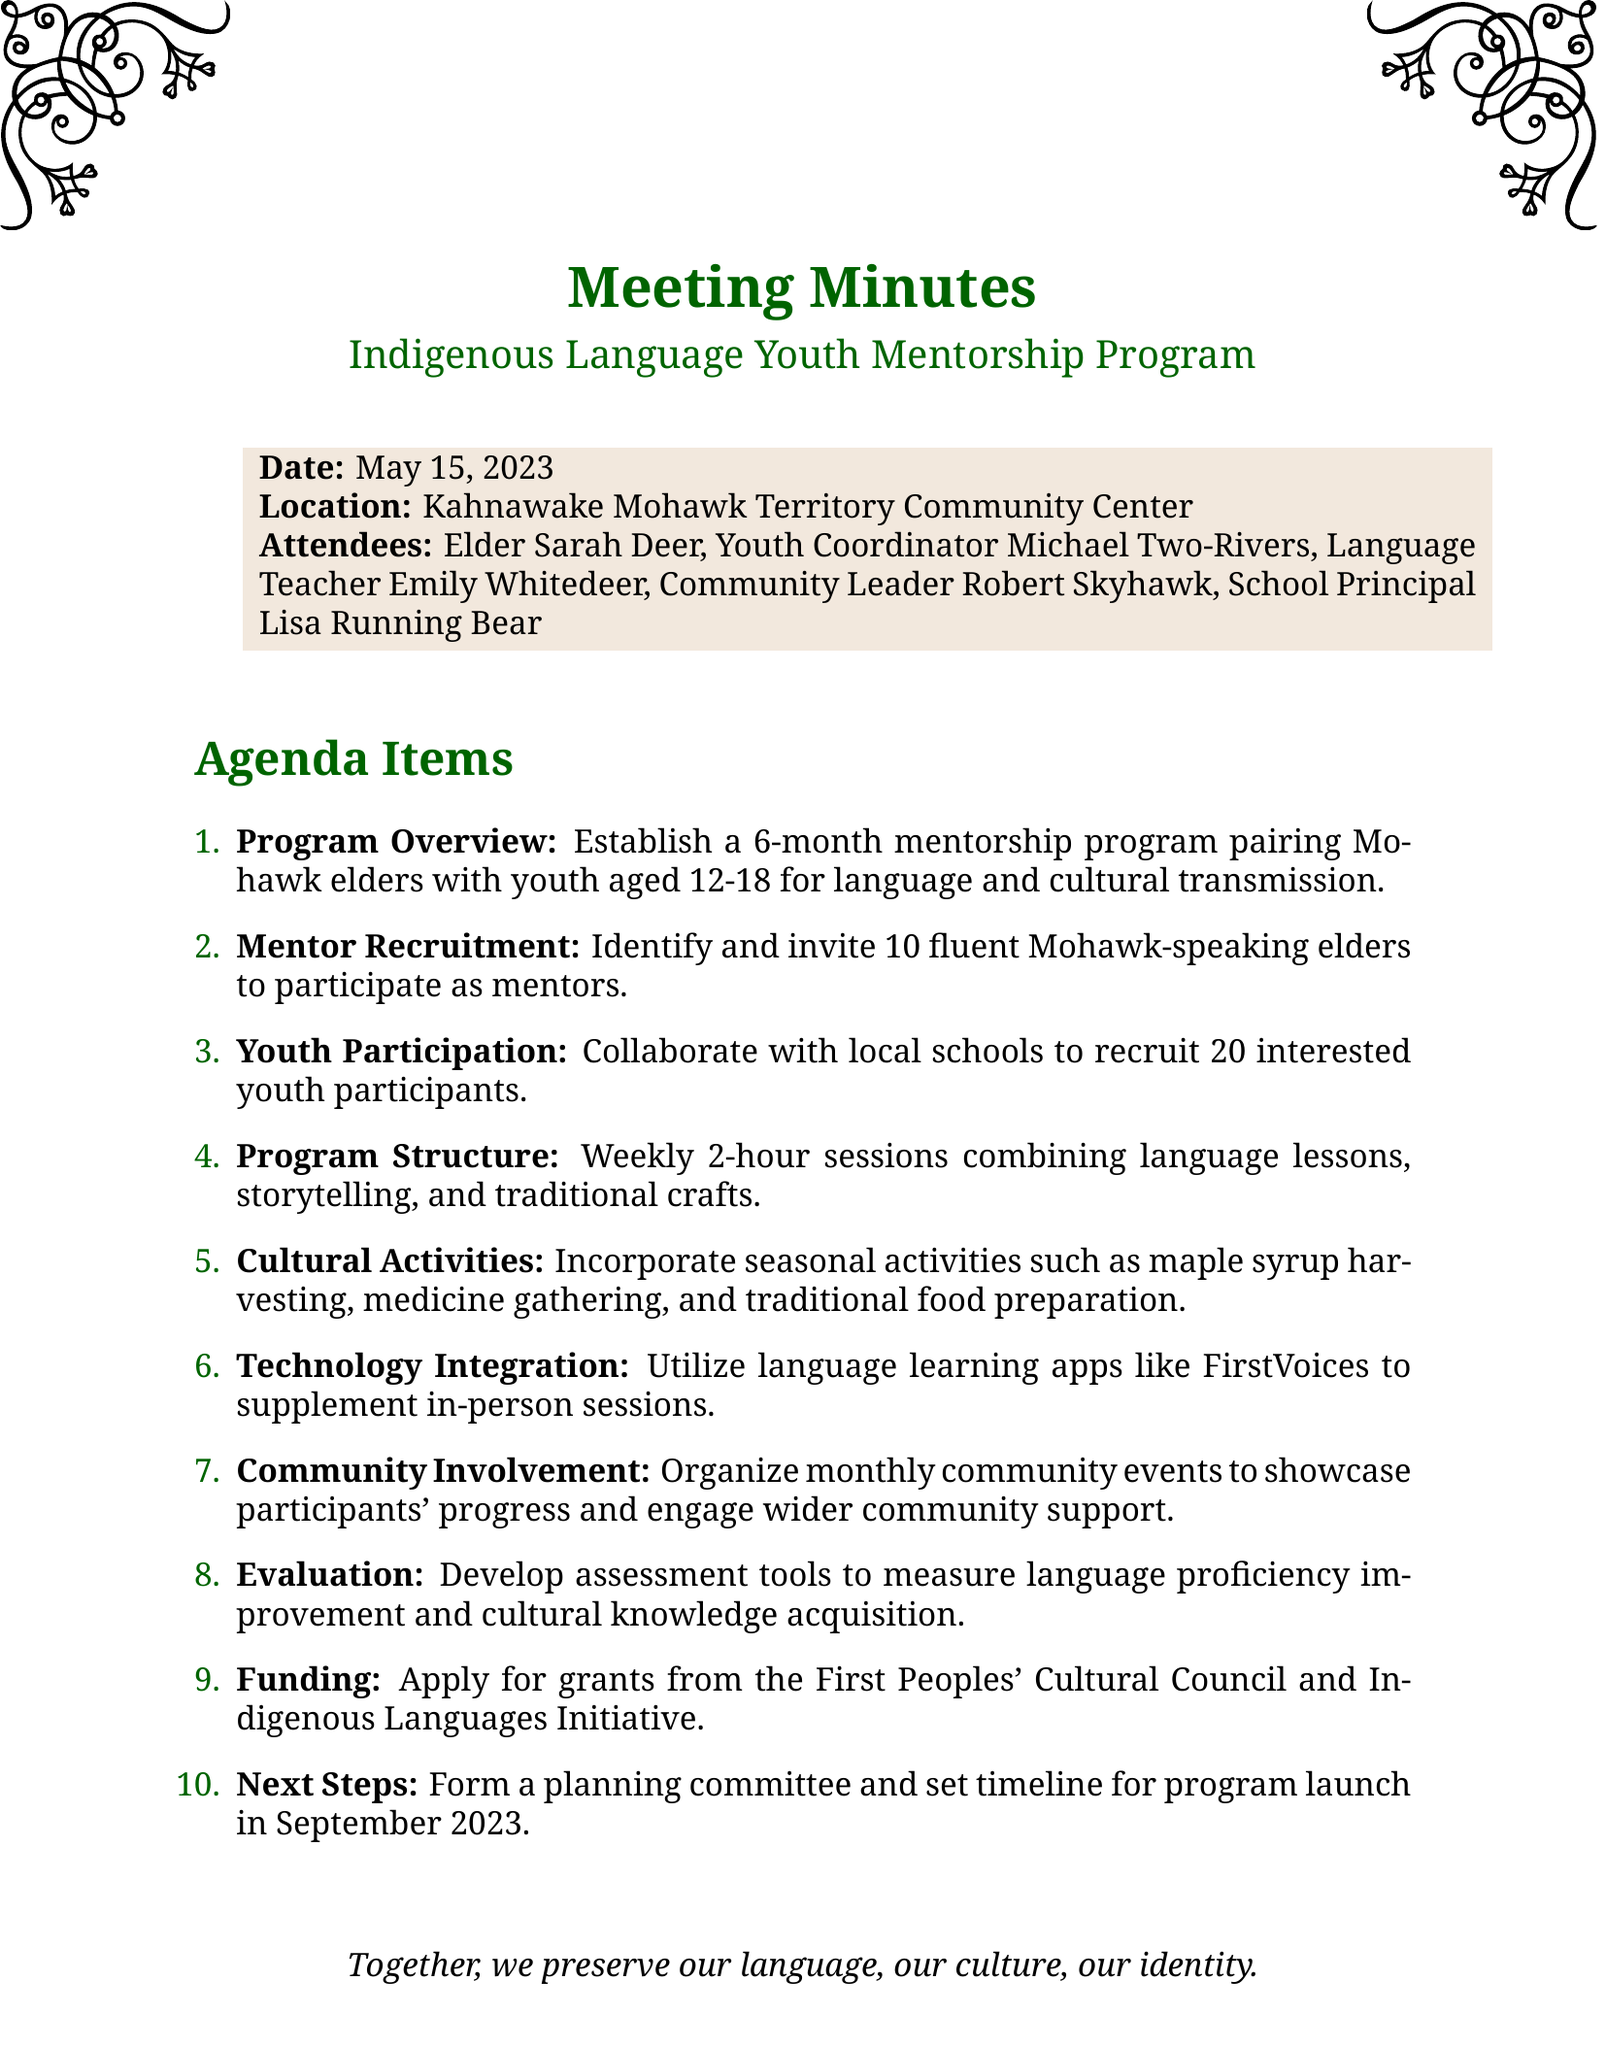what is the meeting title? The meeting title is presented at the beginning of the document.
Answer: Indigenous Language Youth Mentorship Program who is one of the attendees? Attendees are listed after the meeting information, providing names of individuals present.
Answer: Elder Sarah Deer how long is the mentorship program? The duration of the mentorship program is specified in the program overview section.
Answer: 6 months how many youth participants are being recruited? The number of youth participants is indicated in the youth participation agenda item.
Answer: 20 what technology will be used in the program? The technology integration section lists tools intended to enhance the program.
Answer: FirstVoices what seasonal activity is mentioned? The cultural activities section outlines various activities, including seasonal options.
Answer: maple syrup harvesting when is the program set to launch? The next steps section outlines the timeline for the program's launch.
Answer: September 2023 who is responsible for evaluating the program? The evaluation section mentions using assessment tools, implying a responsibility for program evaluation.
Answer: Community Leader Robert Skyhawk how many mentors are being invited? The mentor recruitment agenda item specifies the desired number of mentors for the program.
Answer: 10 